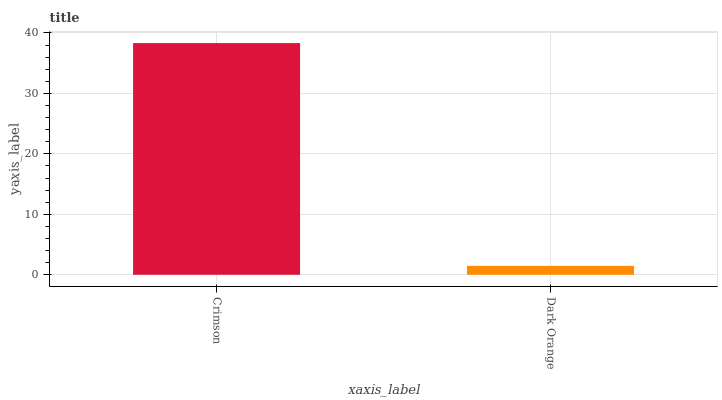Is Dark Orange the minimum?
Answer yes or no. Yes. Is Crimson the maximum?
Answer yes or no. Yes. Is Dark Orange the maximum?
Answer yes or no. No. Is Crimson greater than Dark Orange?
Answer yes or no. Yes. Is Dark Orange less than Crimson?
Answer yes or no. Yes. Is Dark Orange greater than Crimson?
Answer yes or no. No. Is Crimson less than Dark Orange?
Answer yes or no. No. Is Crimson the high median?
Answer yes or no. Yes. Is Dark Orange the low median?
Answer yes or no. Yes. Is Dark Orange the high median?
Answer yes or no. No. Is Crimson the low median?
Answer yes or no. No. 